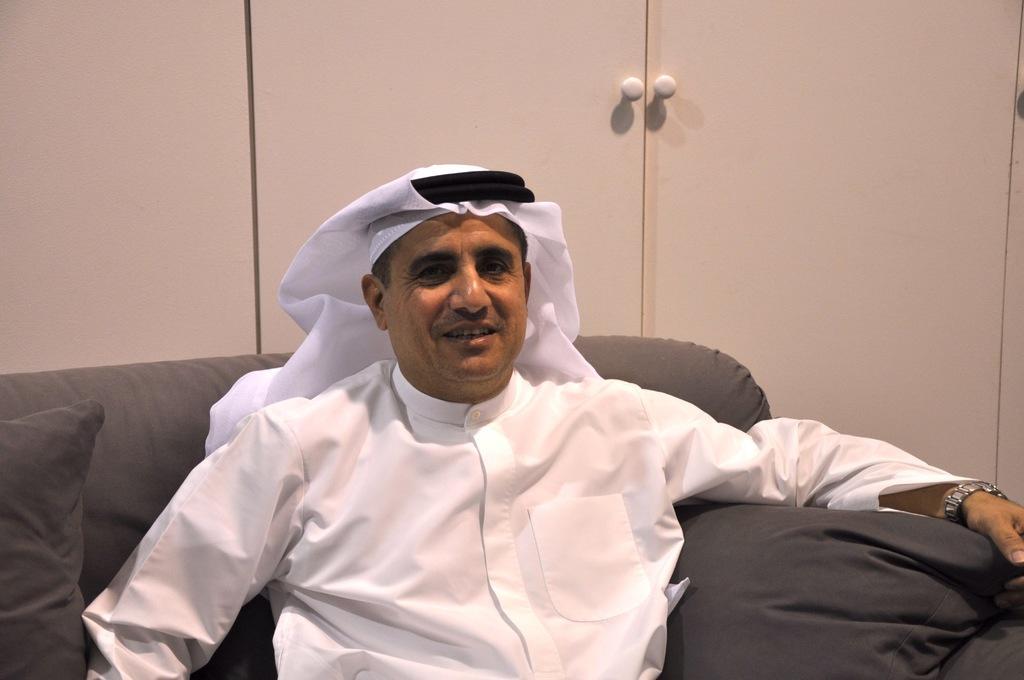Describe this image in one or two sentences. At the bottom of the image a person is sitting on a couch and smiling. Behind the couch we can see a cupboard. 